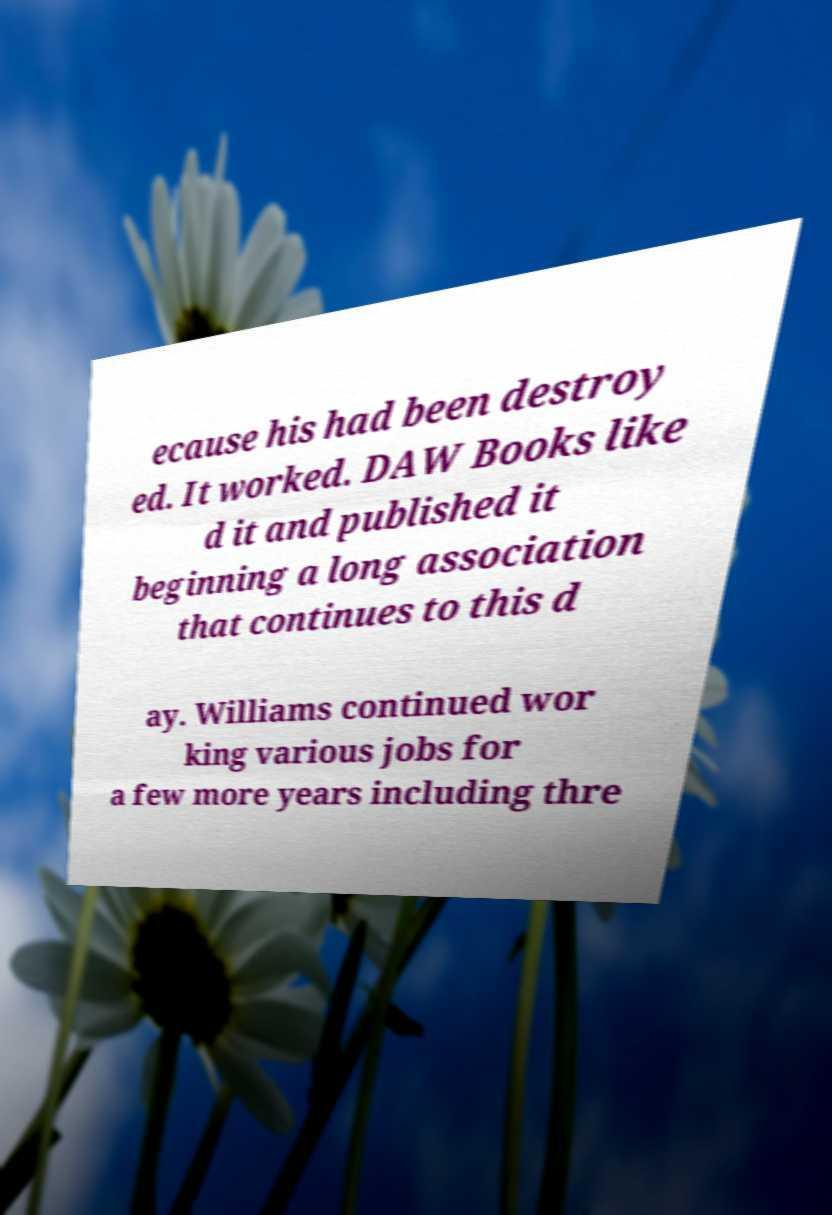There's text embedded in this image that I need extracted. Can you transcribe it verbatim? ecause his had been destroy ed. It worked. DAW Books like d it and published it beginning a long association that continues to this d ay. Williams continued wor king various jobs for a few more years including thre 